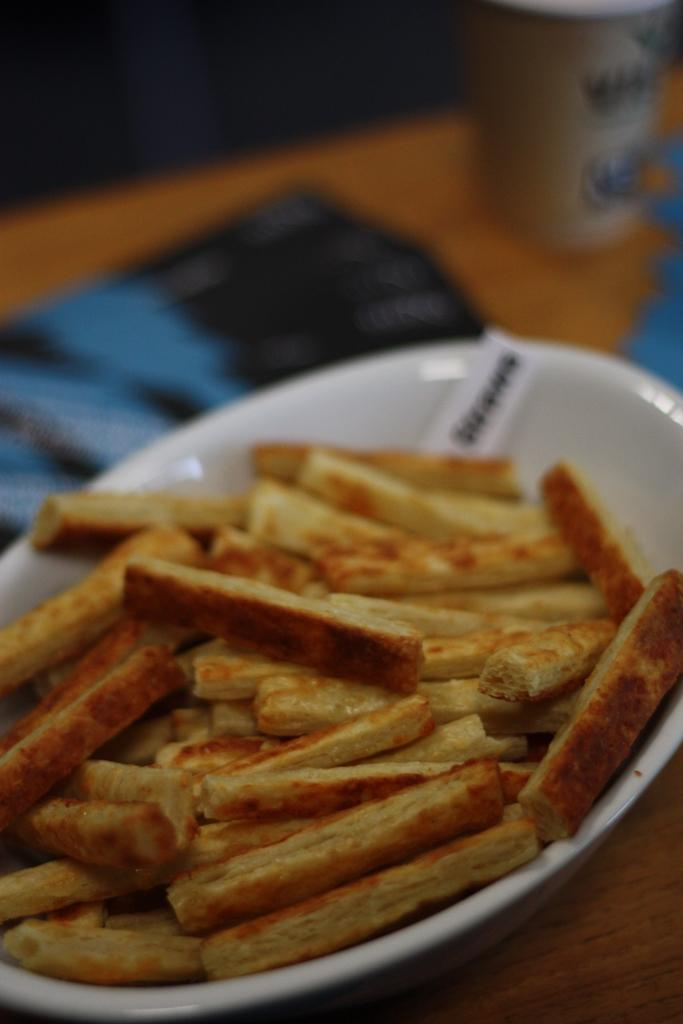What is the main subject of the image? There is a food item in the image. How is the food item presented in the image? The food item is in a white-colored bowl. Where is the bowl located in the image? The bowl is in the middle of the image. Can you see any snakes slithering in the river in the image? There is no river or snakes present in the image; it features a food item in a white-colored bowl. 